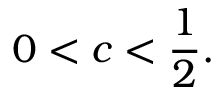<formula> <loc_0><loc_0><loc_500><loc_500>0 < c < { \frac { 1 } { 2 } } .</formula> 